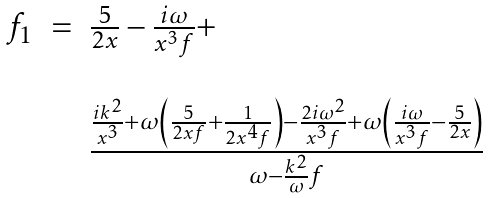<formula> <loc_0><loc_0><loc_500><loc_500>\begin{array} { c c l } f _ { 1 } & = & \frac { 5 } { 2 x } - \frac { i \omega } { x ^ { 3 } f } + \\ & & \\ & & \frac { \frac { i k ^ { 2 } } { x ^ { 3 } } + \omega \left ( \frac { 5 } { 2 x f } + \frac { 1 } { 2 x ^ { 4 } f } \right ) - \frac { 2 i \omega ^ { 2 } } { x ^ { 3 } f } + \omega \left ( \frac { i \omega } { x ^ { 3 } f } - \frac { 5 } { 2 x } \right ) } { \omega - \frac { k ^ { 2 } } { \omega } f } \end{array}</formula> 